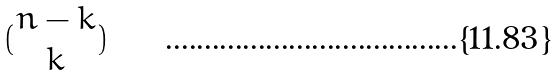<formula> <loc_0><loc_0><loc_500><loc_500>( \begin{matrix} n - k \\ k \end{matrix} )</formula> 